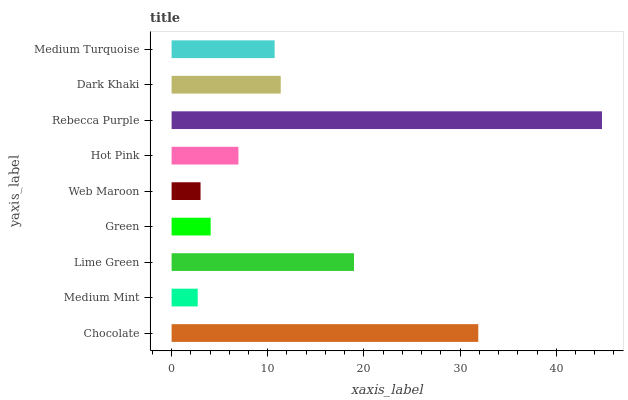Is Medium Mint the minimum?
Answer yes or no. Yes. Is Rebecca Purple the maximum?
Answer yes or no. Yes. Is Lime Green the minimum?
Answer yes or no. No. Is Lime Green the maximum?
Answer yes or no. No. Is Lime Green greater than Medium Mint?
Answer yes or no. Yes. Is Medium Mint less than Lime Green?
Answer yes or no. Yes. Is Medium Mint greater than Lime Green?
Answer yes or no. No. Is Lime Green less than Medium Mint?
Answer yes or no. No. Is Medium Turquoise the high median?
Answer yes or no. Yes. Is Medium Turquoise the low median?
Answer yes or no. Yes. Is Dark Khaki the high median?
Answer yes or no. No. Is Dark Khaki the low median?
Answer yes or no. No. 